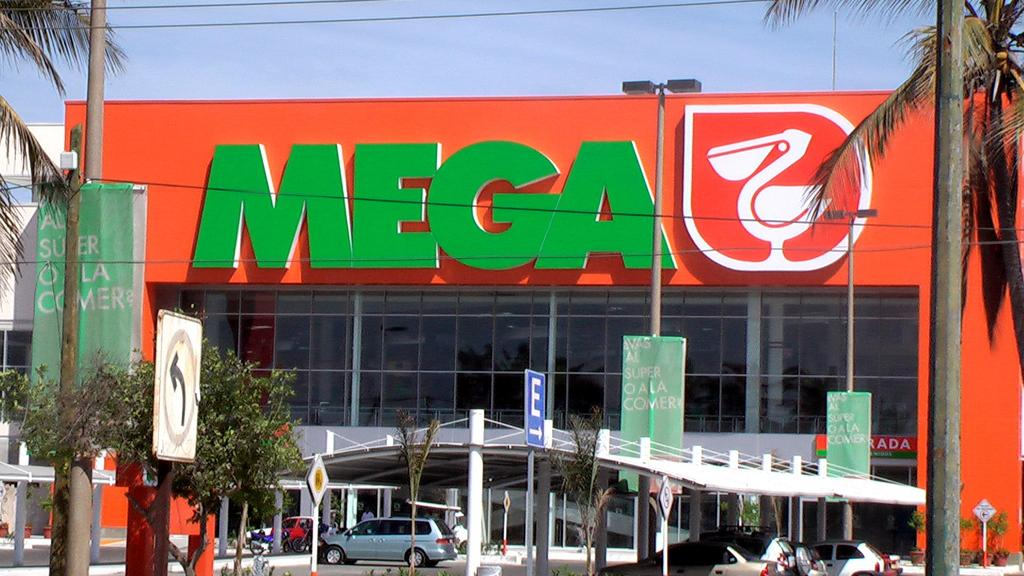What type of vegetation can be seen in the image? There are trees in the image. What is the purpose of the sign in the image? The purpose of the sign is not specified in the image. What materials are the boards made of in the image? The materials of the boards are not specified in the image. What structure is visible in the background of the image? There is a shed in the background of the image. What vehicles are under the shed in the image? There are cars under the shed in the image. What type of establishment is present in the image? There is a mall in the image. What part of the natural environment is visible in the image? The sky is visible in the image. How many bikes are parked in front of the mall in the image? There are no bikes present in the image. Can you tell me how many times the person in the image sneezes? There is no person in the image, and therefore no sneezing can be observed. 